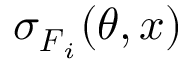Convert formula to latex. <formula><loc_0><loc_0><loc_500><loc_500>\sigma _ { F _ { i } } ( \theta , x )</formula> 